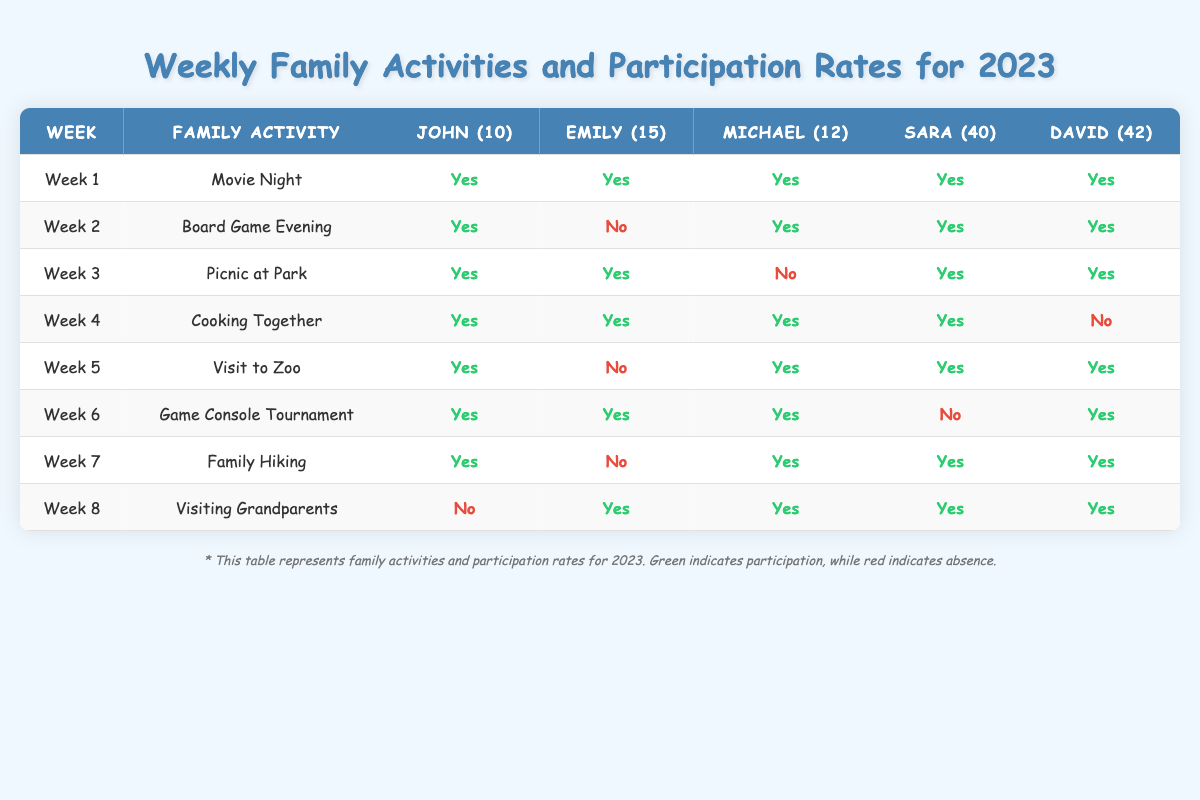What family activity had the highest participation rate? To determine this, I look at each week and count how many participants said "Yes." In Week 1, all 5 participated; in Week 2, 4; in Week 3, 4; in Week 4, 4; in Week 5, 4; in Week 6, 4; in Week 7, 4; and in Week 8, 5. Week 1 and Week 8 both had 5 participants.
Answer: Movie Night and Visiting Grandparents How many family activities did David participate in? I count the "Yes" responses for David across all weeks listed: He participated in Week 1, 2, 3, 5, 6, and 7, making a total of 6 weeks.
Answer: 6 Did Emily participate in more activities than Michael? Emily participated in Weeks 1, 3, 4, 6, and 8, totaling 5 participations. Michael participated in Weeks 1, 2, 3, 4, 5, 6, and 7 totaling 6 participations. Since 5 is less than 6, the answer is no.
Answer: No What was the total number of participations for John across all activities? John participated in Week 1, 2, 3, 4, 5, 6, 7, and the response is "Yes" for all weeks, meaning he participated in all 8 activities.
Answer: 8 In which week did Sara not participate? I check Sara's responses for each week: She did not participate in Week 6.
Answer: Week 6 How many activities had at least 4 participants? I count the weeks with at least 4 "Yes" answers: Week 1 (5), Week 2 (4), Week 3 (4), Week 4 (4), Week 5 (4), Week 6 (4), Week 7 (4), and Week 8 (5). That gives me a total of 8 weeks.
Answer: 8 Which family member had the lowest participation rate? I look at each family member's participation rates. Emily participated in 5 activities, Michael in 6, Sara in 6, David in 6, and John in 8. Emily had the lowest number of participations.
Answer: Emily Calculate the average participation of each family member across all weeks. For John: 8/8 = 1, Emily: 5/8 = 0.625, Michael: 6/8 = 0.75, Sara: 5/8 = 0.625, David: 6/8 = 0.75. The averages are John: 1, Emily: 0.625, Michael: 0.75, Sara: 0.625, David: 0.75.
Answer: John: 1, Emily: 0.625, Michael: 0.75, Sara: 0.625, David: 0.75 How many weeks did at least one family member not participate? I check each week to see if anyone has a "No" response: Week 2 (1), Week 5 (1), Week 6 (1), Week 7 (1), Week 8 (1), which totals to 5 weeks.
Answer: 5 